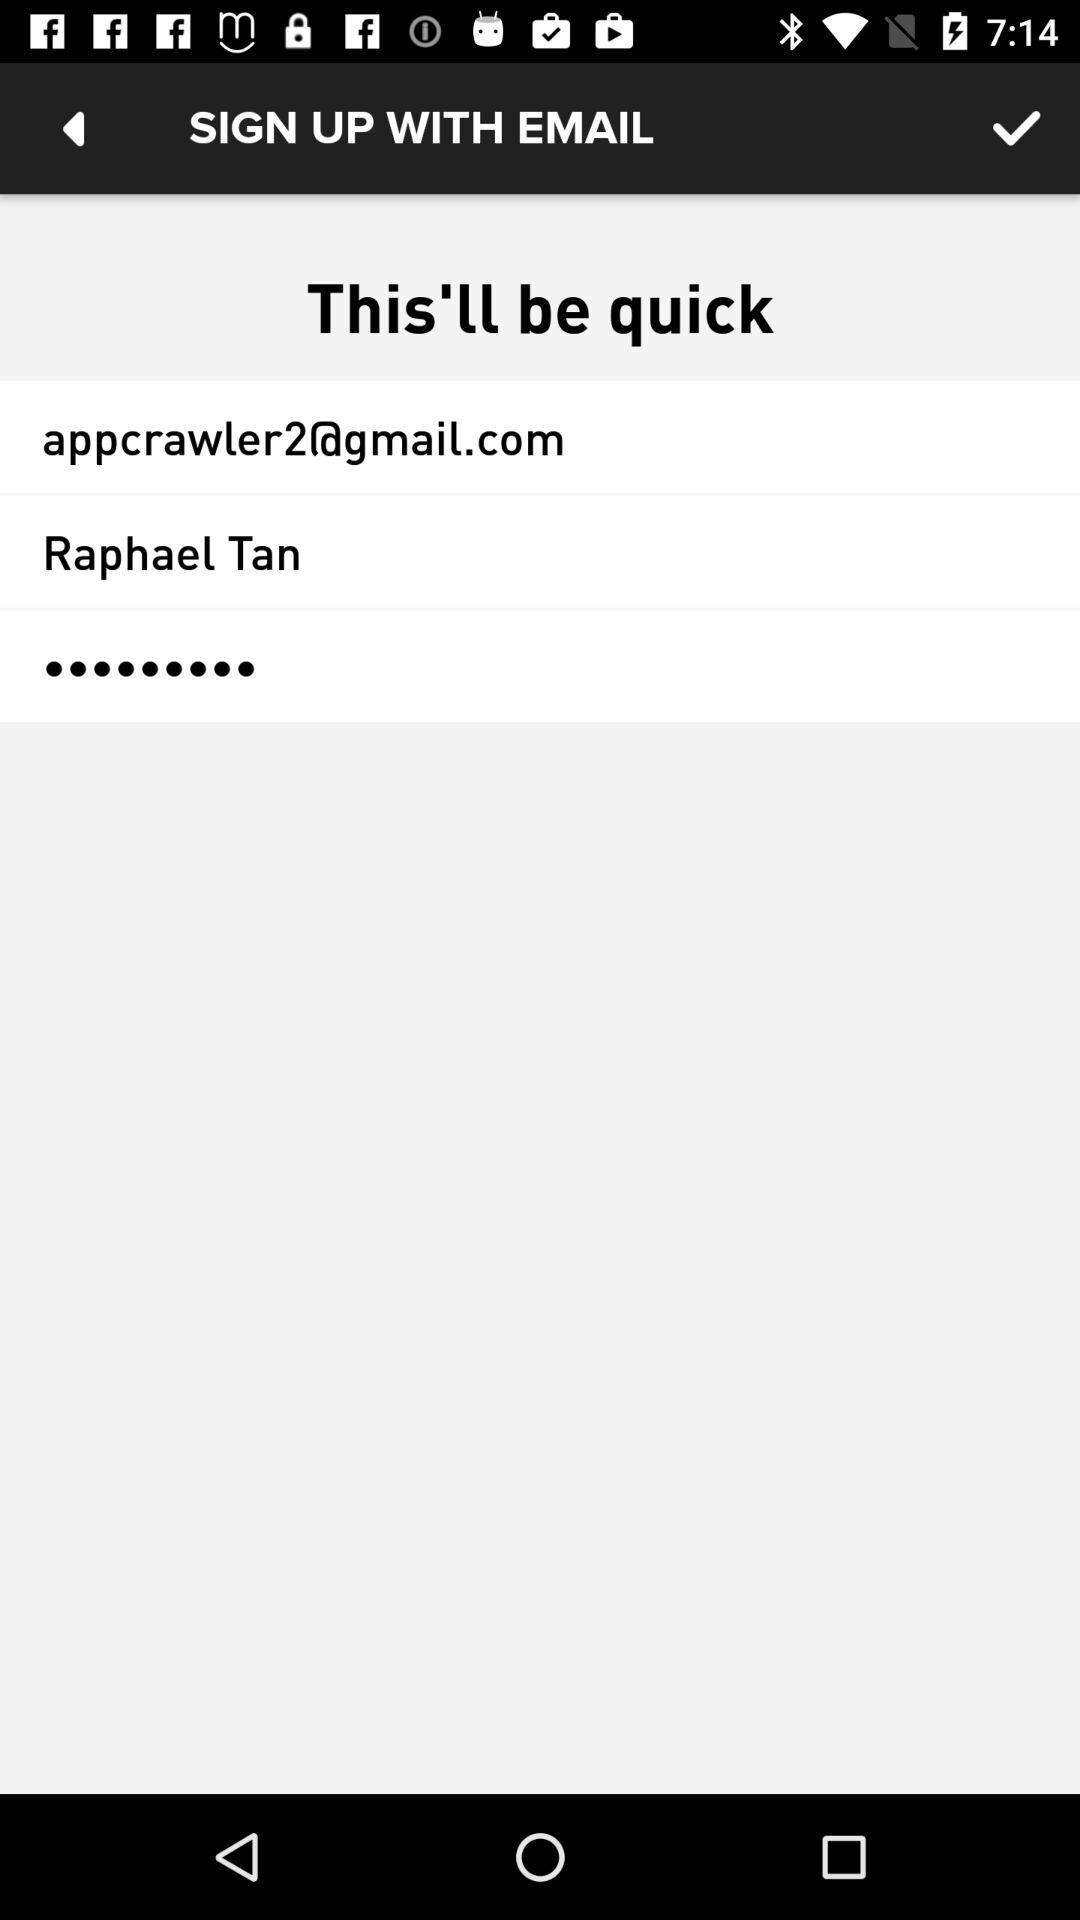What is the email address? The email address is "appcrawler2@gmail.com". 